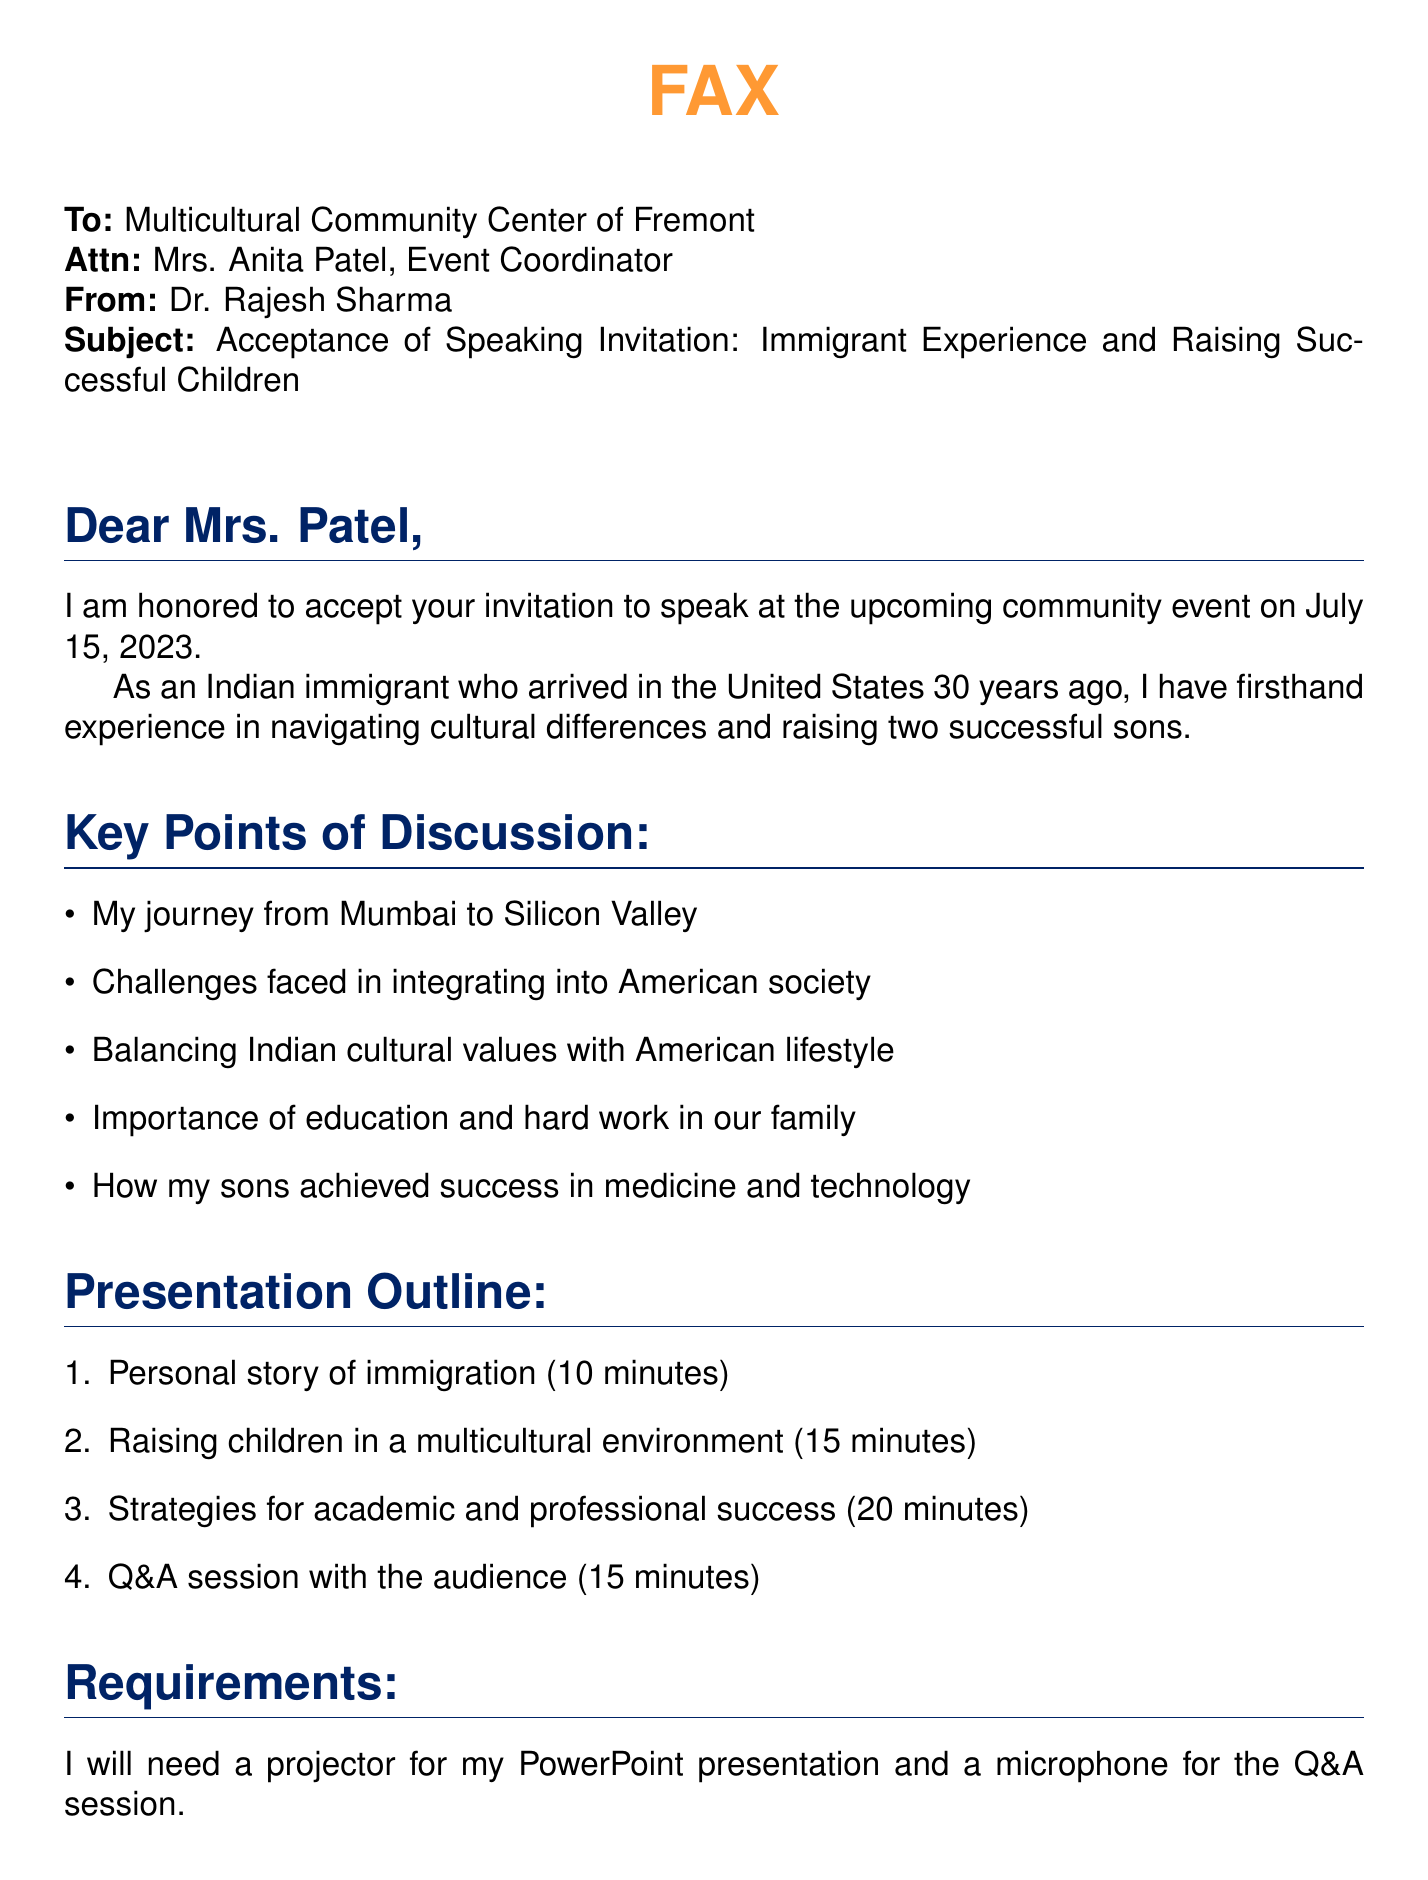What is the date of the event? The event date is mentioned in the "Subject" line of the document.
Answer: July 15, 2023 Who is the event coordinator? The name of the event coordinator is listed in the "To" line of the document.
Answer: Mrs. Anita Patel What is the speaker's profession? The speaker's profession is stated at the end of the document.
Answer: Professor of Computer Science How many minutes is the Q&A session scheduled for? The duration for the Q&A session is specified in the "Presentation Outline" section.
Answer: 15 minutes What additional equipment does the speaker require? The requirements listed at the end of the document specify the necessary equipment.
Answer: Projector and microphone What are the two fields where the speaker's sons achieved success? The speaker mentions his sons' success fields in the "Key Points of Discussion" section.
Answer: Medicine and technology What is the speaker's email address? The speaker's email address is provided in the contact information at the end of the document.
Answer: rajesh.sharma@email.com What narrative does the speaker include in his presentation? The speaker outlines his personal experience in the "Presentation Outline" section.
Answer: Personal story of immigration 